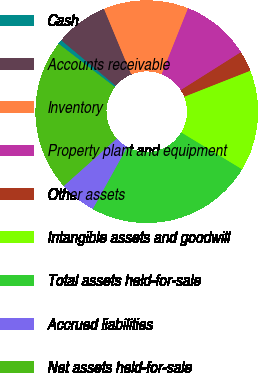<chart> <loc_0><loc_0><loc_500><loc_500><pie_chart><fcel>Cash<fcel>Accounts receivable<fcel>Inventory<fcel>Property plant and equipment<fcel>Other assets<fcel>Intangible assets and goodwill<fcel>Total assets held-for-sale<fcel>Accrued liabilities<fcel>Net assets held-for-sale<nl><fcel>0.65%<fcel>7.65%<fcel>12.32%<fcel>9.99%<fcel>2.98%<fcel>14.65%<fcel>24.39%<fcel>5.32%<fcel>22.05%<nl></chart> 